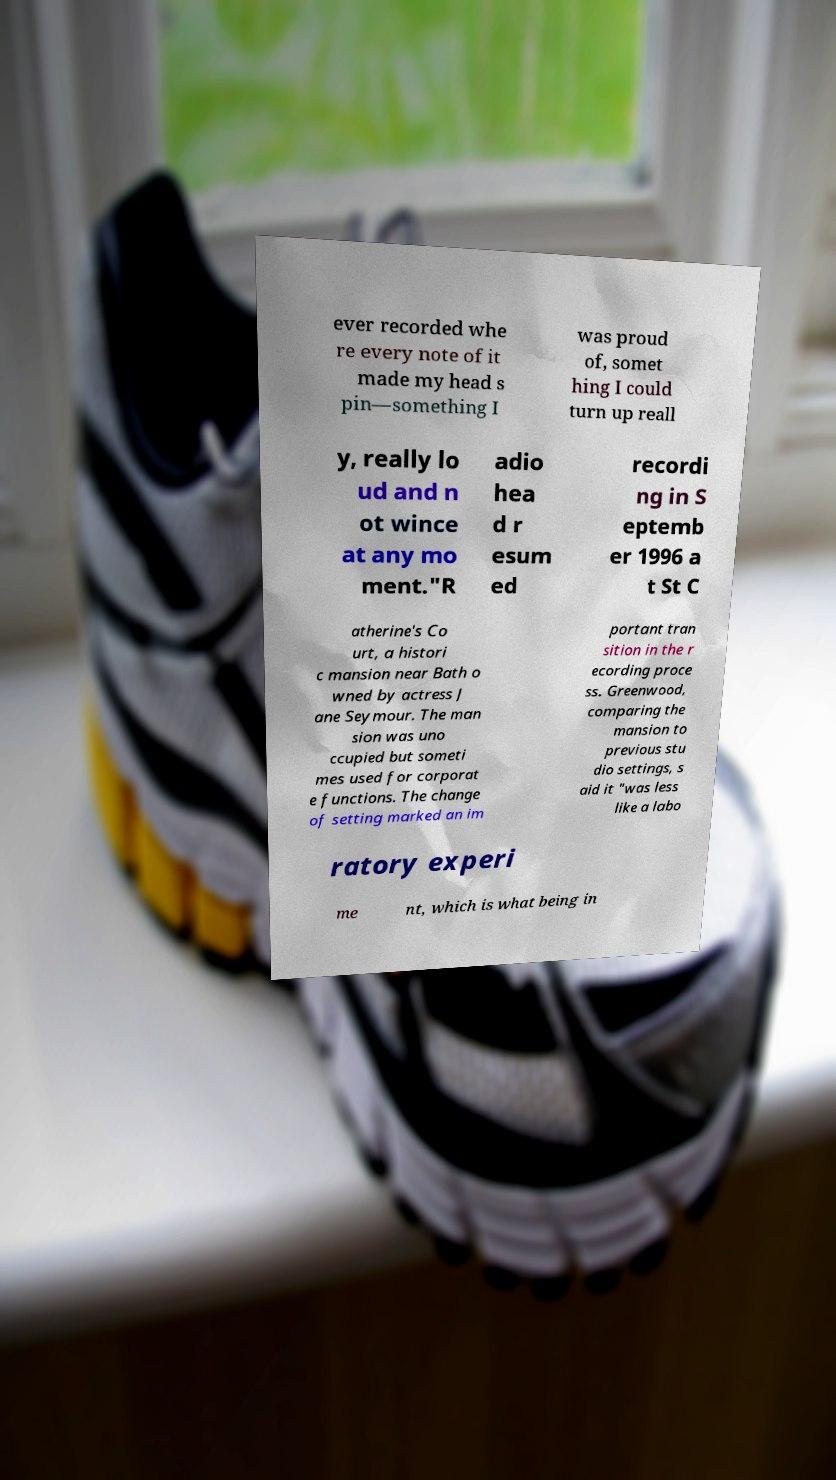I need the written content from this picture converted into text. Can you do that? ever recorded whe re every note of it made my head s pin—something I was proud of, somet hing I could turn up reall y, really lo ud and n ot wince at any mo ment."R adio hea d r esum ed recordi ng in S eptemb er 1996 a t St C atherine's Co urt, a histori c mansion near Bath o wned by actress J ane Seymour. The man sion was uno ccupied but someti mes used for corporat e functions. The change of setting marked an im portant tran sition in the r ecording proce ss. Greenwood, comparing the mansion to previous stu dio settings, s aid it "was less like a labo ratory experi me nt, which is what being in 